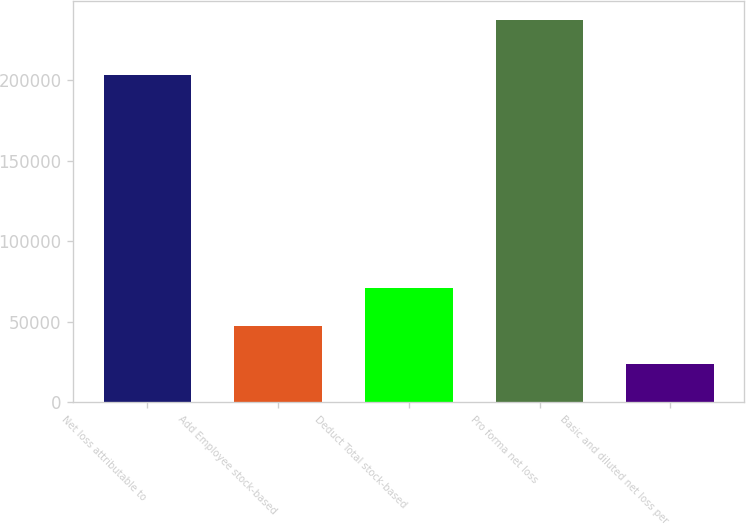Convert chart. <chart><loc_0><loc_0><loc_500><loc_500><bar_chart><fcel>Net loss attributable to<fcel>Add Employee stock-based<fcel>Deduct Total stock-based<fcel>Pro forma net loss<fcel>Basic and diluted net loss per<nl><fcel>203417<fcel>47402.2<fcel>71102.2<fcel>237002<fcel>23702.2<nl></chart> 